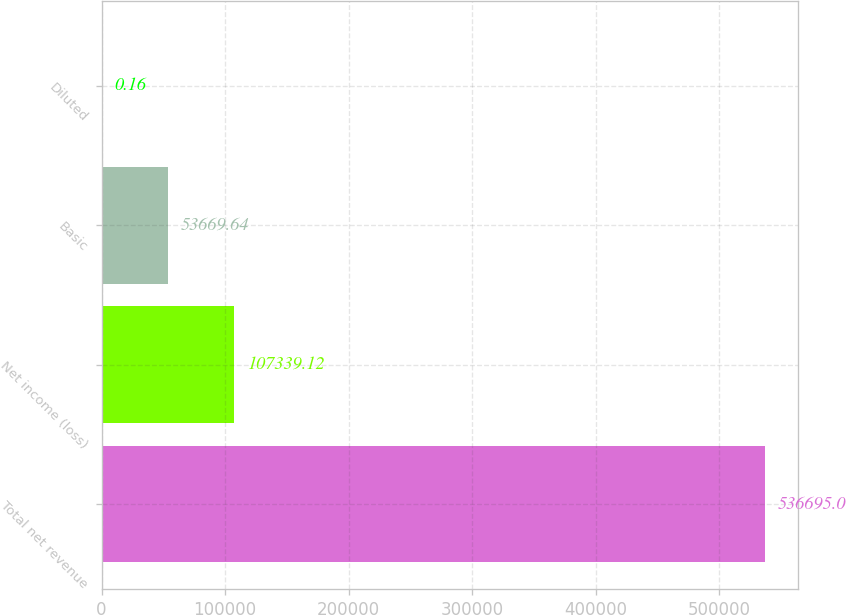Convert chart to OTSL. <chart><loc_0><loc_0><loc_500><loc_500><bar_chart><fcel>Total net revenue<fcel>Net income (loss)<fcel>Basic<fcel>Diluted<nl><fcel>536695<fcel>107339<fcel>53669.6<fcel>0.16<nl></chart> 